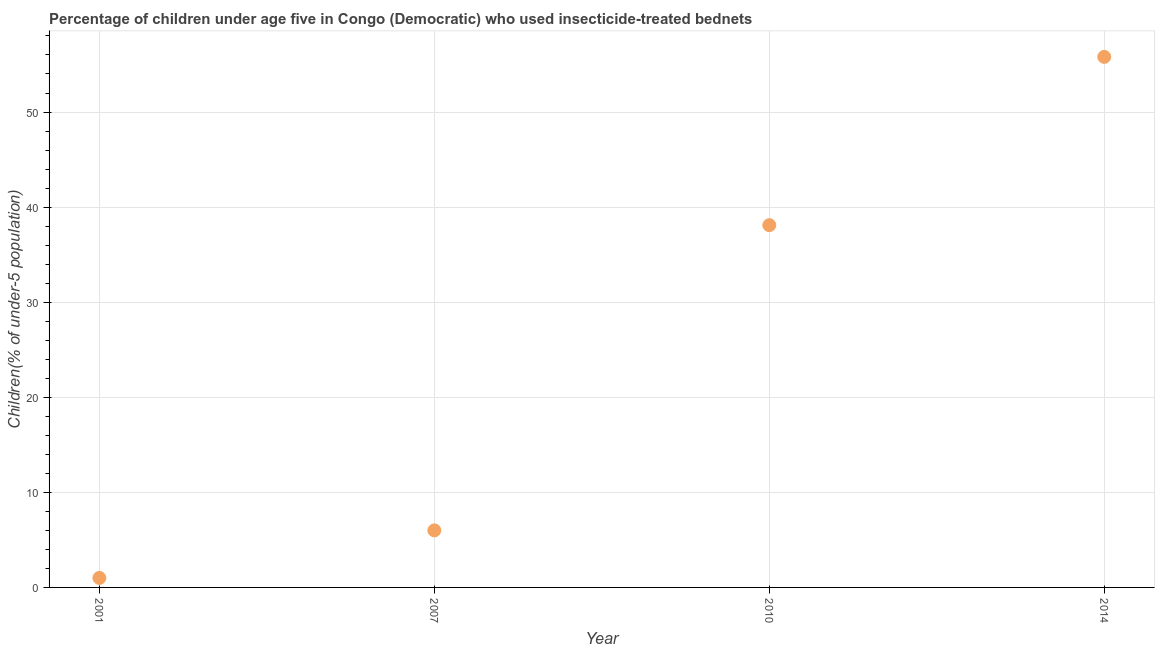What is the percentage of children who use of insecticide-treated bed nets in 2001?
Provide a succinct answer. 1. Across all years, what is the maximum percentage of children who use of insecticide-treated bed nets?
Offer a terse response. 55.8. Across all years, what is the minimum percentage of children who use of insecticide-treated bed nets?
Make the answer very short. 1. In which year was the percentage of children who use of insecticide-treated bed nets maximum?
Ensure brevity in your answer.  2014. In which year was the percentage of children who use of insecticide-treated bed nets minimum?
Your response must be concise. 2001. What is the sum of the percentage of children who use of insecticide-treated bed nets?
Make the answer very short. 100.9. What is the difference between the percentage of children who use of insecticide-treated bed nets in 2007 and 2010?
Make the answer very short. -32.1. What is the average percentage of children who use of insecticide-treated bed nets per year?
Make the answer very short. 25.23. What is the median percentage of children who use of insecticide-treated bed nets?
Keep it short and to the point. 22.05. Do a majority of the years between 2001 and 2014 (inclusive) have percentage of children who use of insecticide-treated bed nets greater than 40 %?
Make the answer very short. No. What is the ratio of the percentage of children who use of insecticide-treated bed nets in 2007 to that in 2014?
Ensure brevity in your answer.  0.11. Is the percentage of children who use of insecticide-treated bed nets in 2007 less than that in 2014?
Provide a short and direct response. Yes. What is the difference between the highest and the second highest percentage of children who use of insecticide-treated bed nets?
Your response must be concise. 17.7. Is the sum of the percentage of children who use of insecticide-treated bed nets in 2007 and 2014 greater than the maximum percentage of children who use of insecticide-treated bed nets across all years?
Provide a succinct answer. Yes. What is the difference between the highest and the lowest percentage of children who use of insecticide-treated bed nets?
Your response must be concise. 54.8. How many years are there in the graph?
Provide a short and direct response. 4. What is the difference between two consecutive major ticks on the Y-axis?
Your answer should be compact. 10. What is the title of the graph?
Your answer should be very brief. Percentage of children under age five in Congo (Democratic) who used insecticide-treated bednets. What is the label or title of the Y-axis?
Keep it short and to the point. Children(% of under-5 population). What is the Children(% of under-5 population) in 2007?
Offer a very short reply. 6. What is the Children(% of under-5 population) in 2010?
Provide a succinct answer. 38.1. What is the Children(% of under-5 population) in 2014?
Make the answer very short. 55.8. What is the difference between the Children(% of under-5 population) in 2001 and 2007?
Offer a terse response. -5. What is the difference between the Children(% of under-5 population) in 2001 and 2010?
Your answer should be compact. -37.1. What is the difference between the Children(% of under-5 population) in 2001 and 2014?
Ensure brevity in your answer.  -54.8. What is the difference between the Children(% of under-5 population) in 2007 and 2010?
Ensure brevity in your answer.  -32.1. What is the difference between the Children(% of under-5 population) in 2007 and 2014?
Your response must be concise. -49.8. What is the difference between the Children(% of under-5 population) in 2010 and 2014?
Provide a short and direct response. -17.7. What is the ratio of the Children(% of under-5 population) in 2001 to that in 2007?
Provide a short and direct response. 0.17. What is the ratio of the Children(% of under-5 population) in 2001 to that in 2010?
Ensure brevity in your answer.  0.03. What is the ratio of the Children(% of under-5 population) in 2001 to that in 2014?
Your answer should be compact. 0.02. What is the ratio of the Children(% of under-5 population) in 2007 to that in 2010?
Keep it short and to the point. 0.16. What is the ratio of the Children(% of under-5 population) in 2007 to that in 2014?
Provide a succinct answer. 0.11. What is the ratio of the Children(% of under-5 population) in 2010 to that in 2014?
Provide a succinct answer. 0.68. 